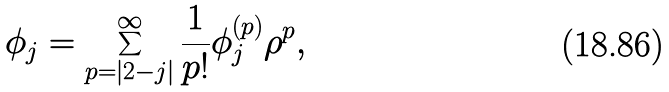<formula> <loc_0><loc_0><loc_500><loc_500>\phi _ { j } = \sum _ { p = | 2 - j | } ^ { \infty } \frac { 1 } { p ! } \phi _ { j } ^ { ( p ) } \rho ^ { p } ,</formula> 